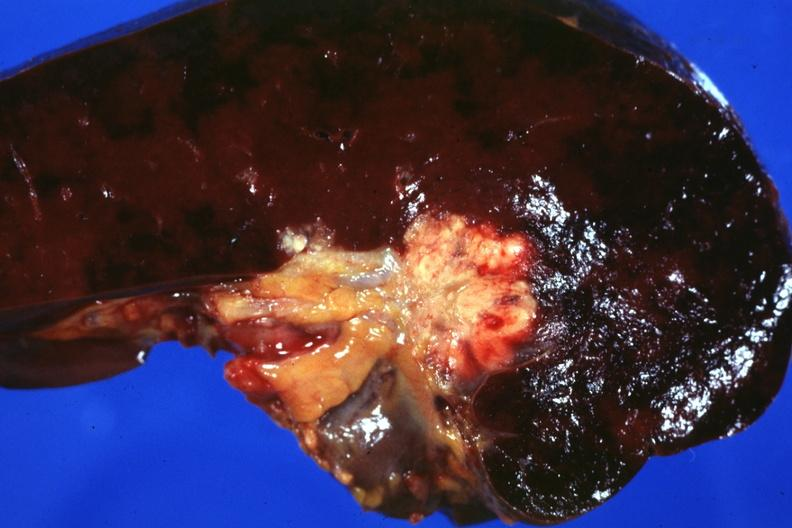does this photo make one wonder whether node metastases spread into the spleen in this case?
Answer the question using a single word or phrase. Yes 